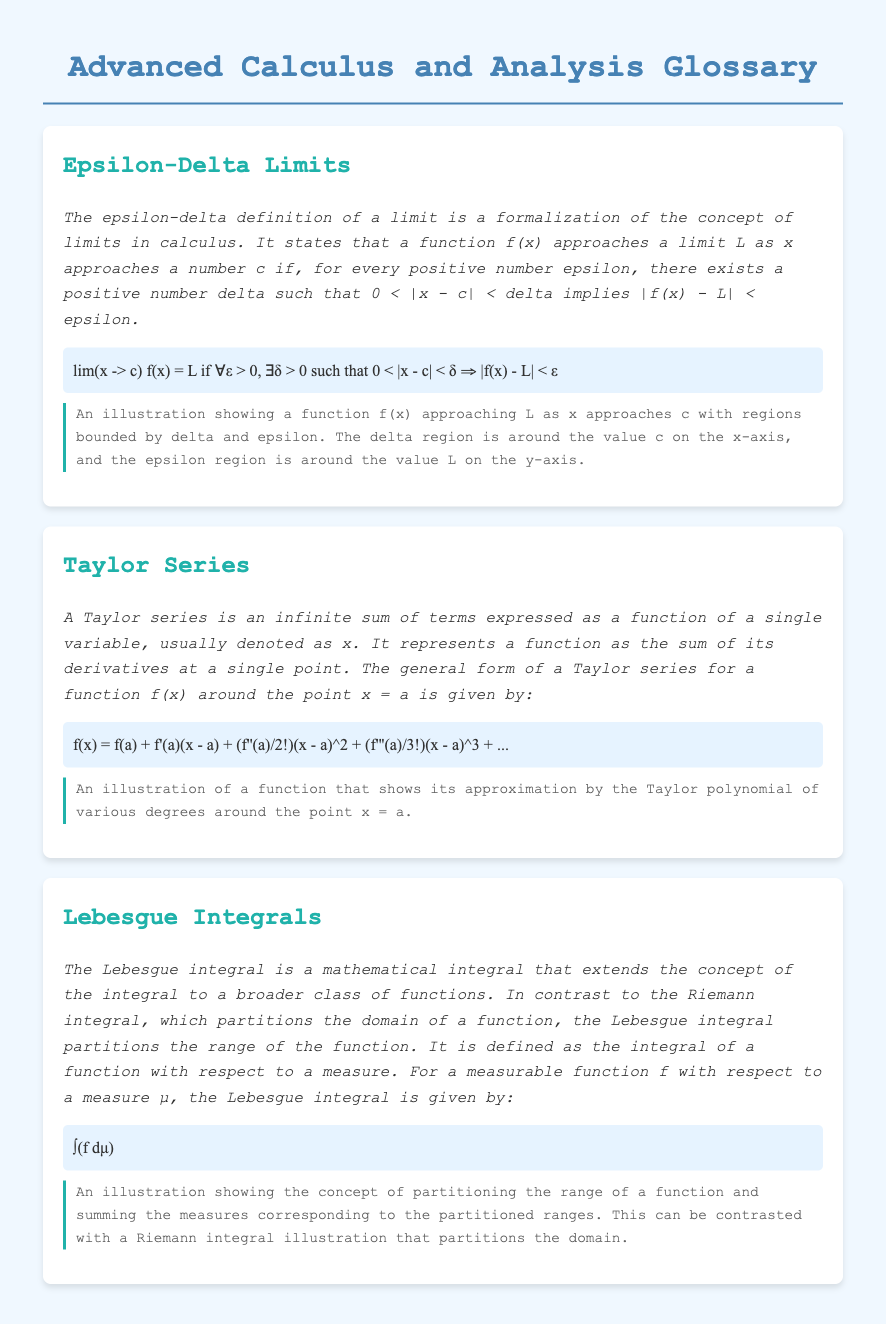What is the epsilon-delta definition of a limit? The epsilon-delta definition of a limit formalizes the concept of limits in calculus, stating that a function f(x) approaches a limit L as x approaches a number c if certain conditions involving epsilon and delta hold.
Answer: A formalization of limits What is the general form of a Taylor series? The general form of a Taylor series for a function f(x) around the point x = a expresses the function as the sum of its derivatives at that point.
Answer: Infinite sum of terms What does the symbol ∫ represent in the context of Lebesgue integrals? The symbol ∫ in the Lebesgue integral represents the integral of a function with respect to a measure.
Answer: Integral What are the two types of integrals compared in the document? The document contrasts the Lebesgue integral and the Riemann integral regarding how they handle partitions of functions.
Answer: Lebesgue and Riemann integrals What distinct approach does the Lebesgue integral take compared to the Riemann integral? The Lebesgue integral partitions the range of a function, whereas the Riemann integral partitions the domain of a function.
Answer: Range vs. domain partitioning What function does the Taylor series approximate? The Taylor series approximates a function f(x) around a specific point x = a using its derivatives at that point.
Answer: f(x) How does the epsilon-delta definition handle variables? In the epsilon-delta definition, it involves two variables: epsilon and delta, where epsilon is a positive number, and delta is also a positive number that satisfies a specific condition.
Answer: Epsilon and delta What is a key feature of the diagrams in the document? The diagrams illustrate concepts such as the approach of functions to limits, the approximation of functions by Taylor polynomials, and the partitioning of ranges in integral definitions.
Answer: Illustrative concepts What language is used in the document for displaying equations? The document uses a serif font called 'Latin Modern Math' for displaying mathematical equations and expressions.
Answer: Latin Modern Math 